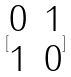<formula> <loc_0><loc_0><loc_500><loc_500>[ \begin{matrix} 0 & 1 \\ 1 & 0 \end{matrix} ]</formula> 